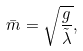Convert formula to latex. <formula><loc_0><loc_0><loc_500><loc_500>\bar { m } = \sqrt { \frac { g } { \tilde { \lambda } } } ,</formula> 